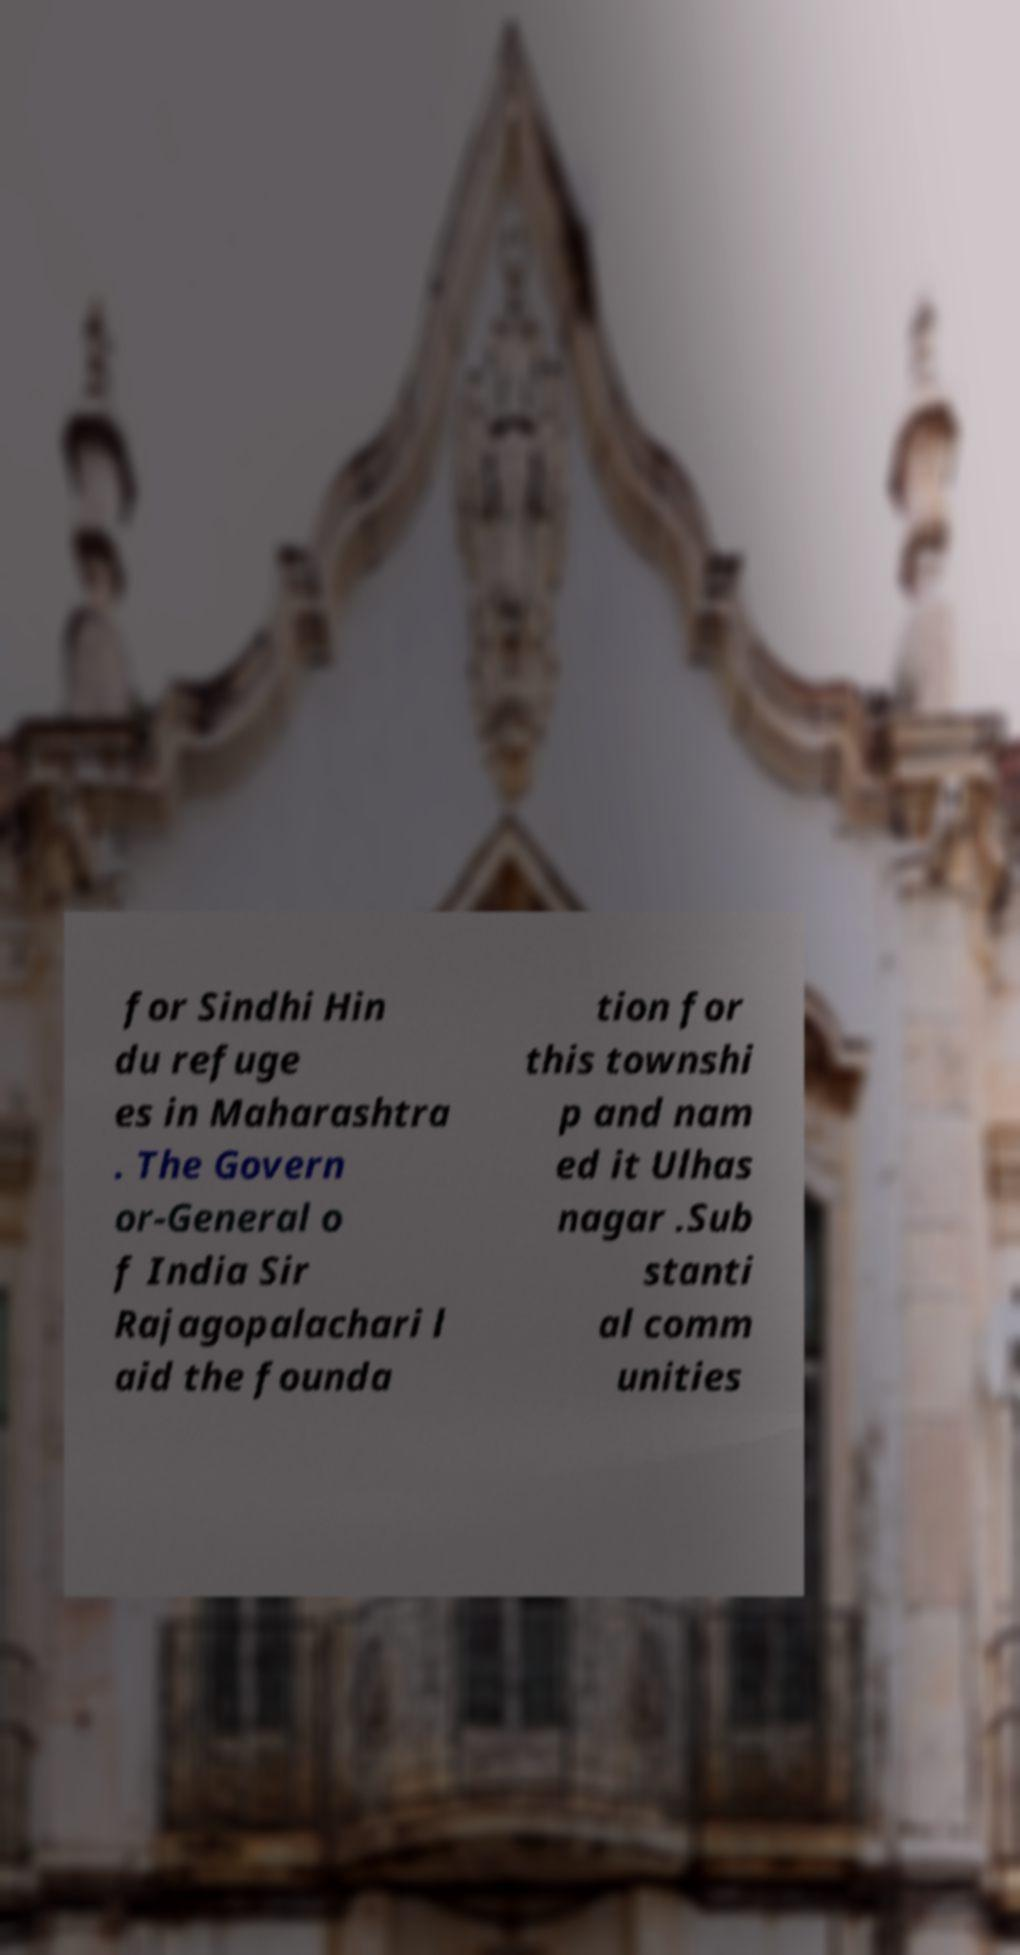I need the written content from this picture converted into text. Can you do that? for Sindhi Hin du refuge es in Maharashtra . The Govern or-General o f India Sir Rajagopalachari l aid the founda tion for this townshi p and nam ed it Ulhas nagar .Sub stanti al comm unities 